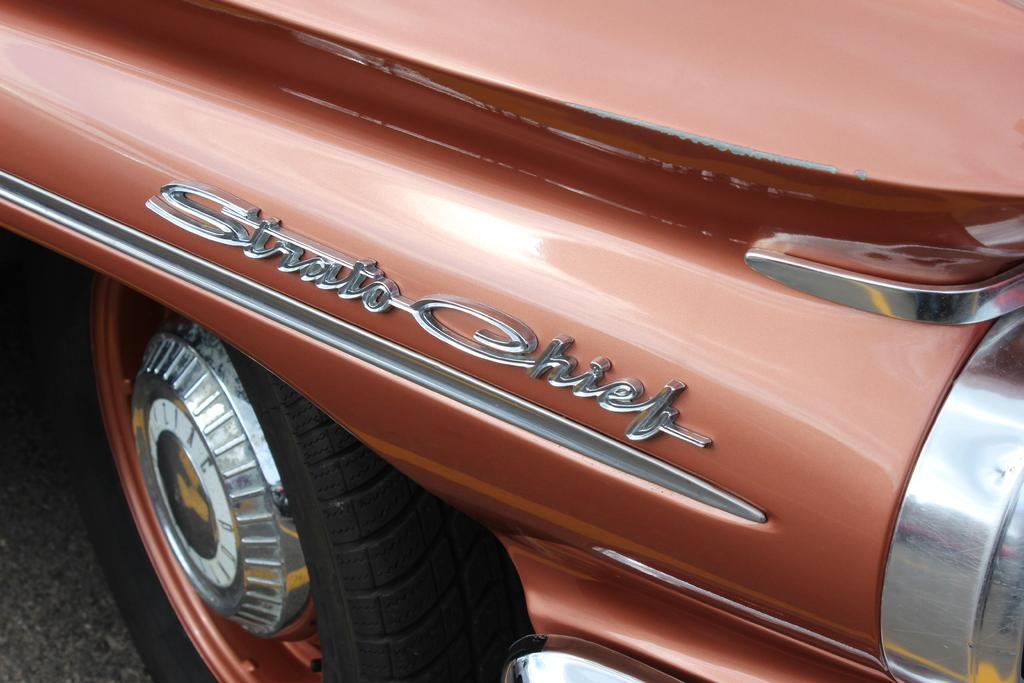What is the main subject of the image? The main subject of the image is a vehicle. Can you describe any specific features or details about the vehicle? Yes, there is writing on the vehicle. Reasoning: Let' Let's think step by step in order to produce the conversation. We start by identifying the main subject of the image, which is the vehicle. Then, we focus on a specific detail about the vehicle that is mentioned in the facts, which is the writing on it. By doing so, we ensure that each question can be answered definitively with the information given. Absurd Question/Answer: What type of loaf is being served in the vehicle? There is no loaf present in the image; it only features a vehicle with writing on it. 